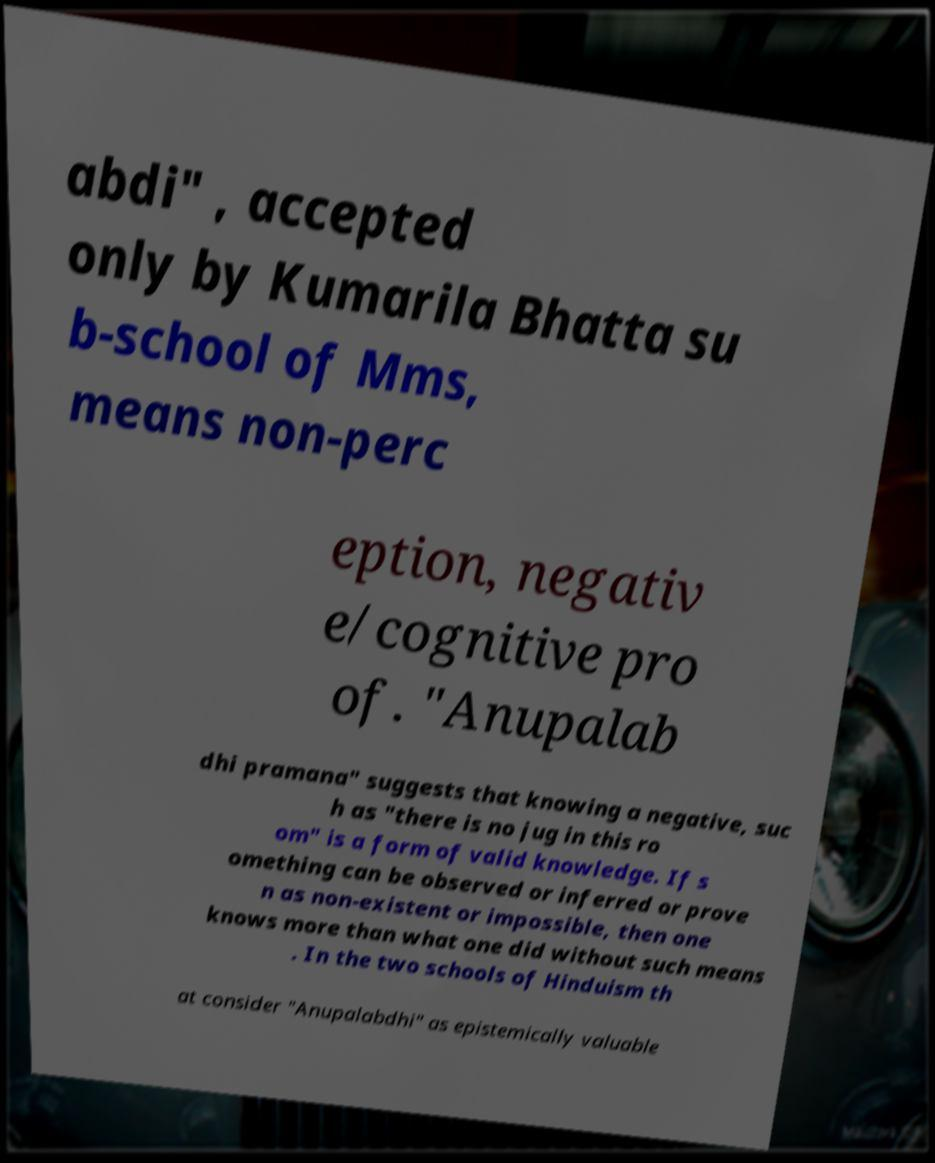Please read and relay the text visible in this image. What does it say? abdi" , accepted only by Kumarila Bhatta su b-school of Mms, means non-perc eption, negativ e/cognitive pro of. "Anupalab dhi pramana" suggests that knowing a negative, suc h as "there is no jug in this ro om" is a form of valid knowledge. If s omething can be observed or inferred or prove n as non-existent or impossible, then one knows more than what one did without such means . In the two schools of Hinduism th at consider "Anupalabdhi" as epistemically valuable 